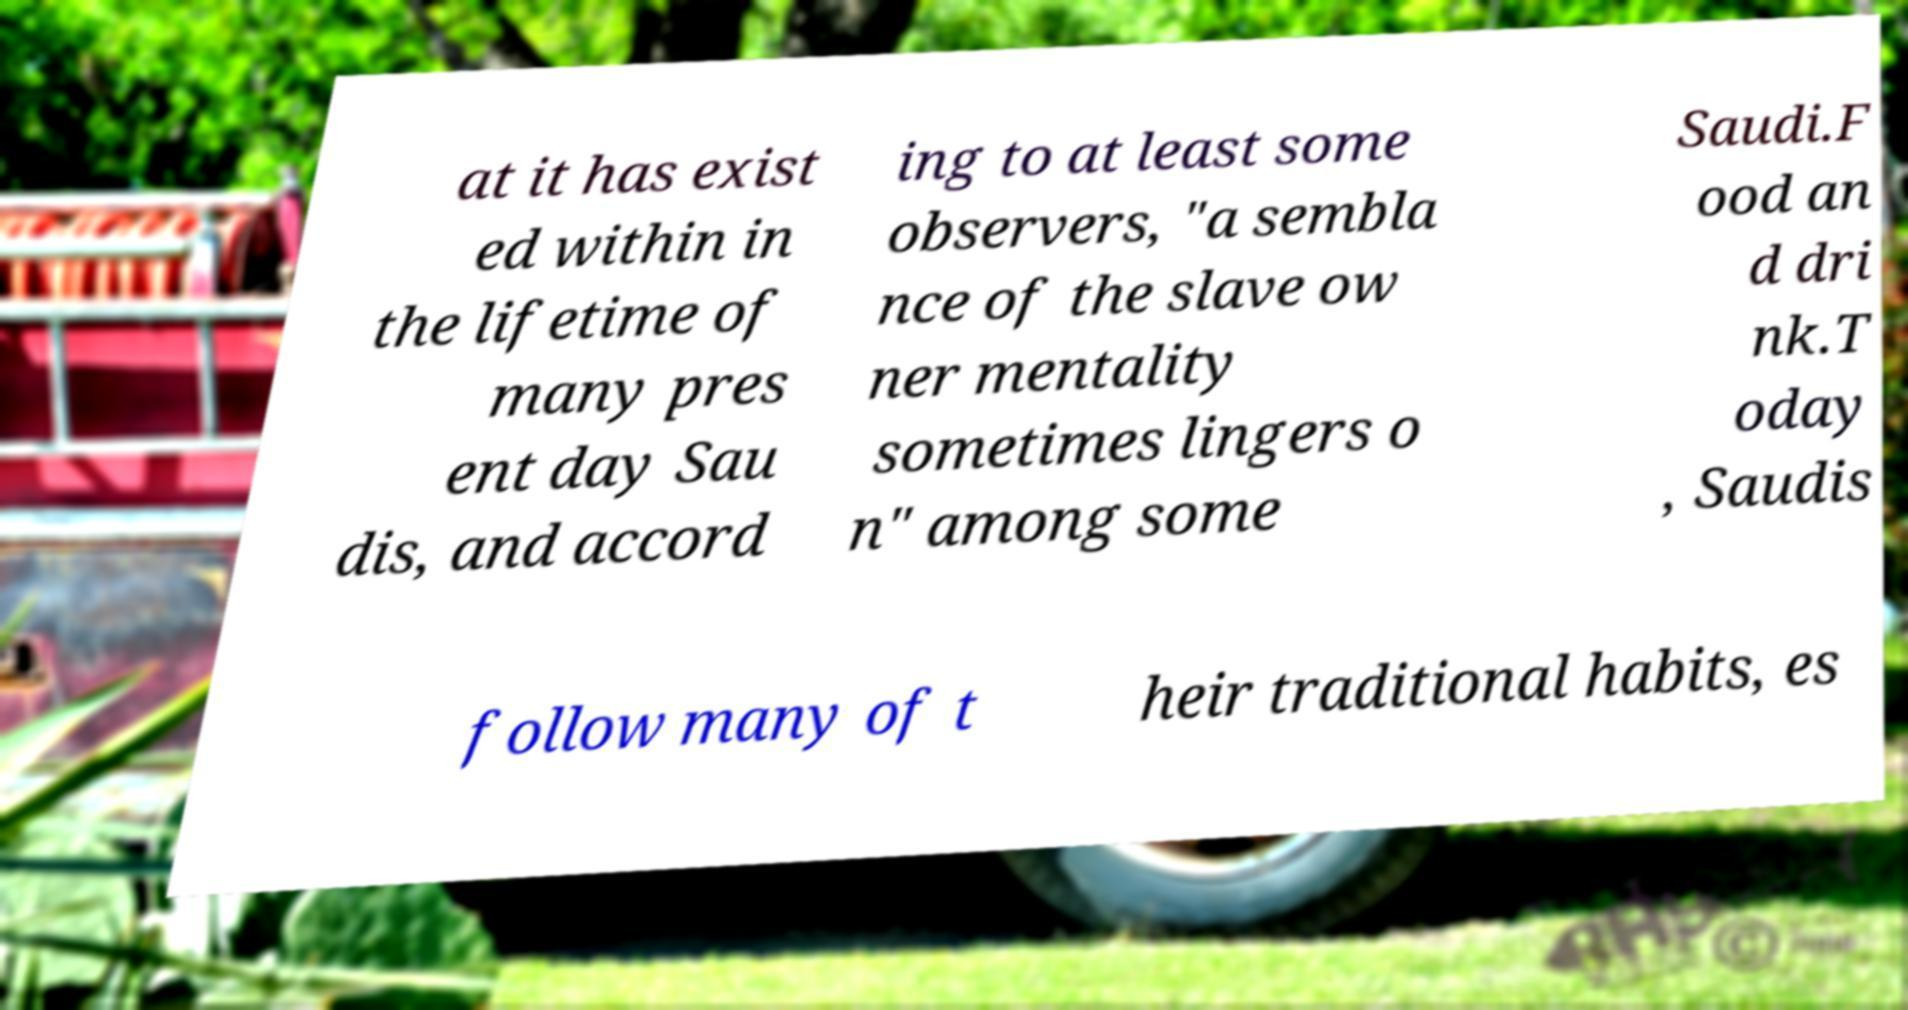Please read and relay the text visible in this image. What does it say? at it has exist ed within in the lifetime of many pres ent day Sau dis, and accord ing to at least some observers, "a sembla nce of the slave ow ner mentality sometimes lingers o n" among some Saudi.F ood an d dri nk.T oday , Saudis follow many of t heir traditional habits, es 